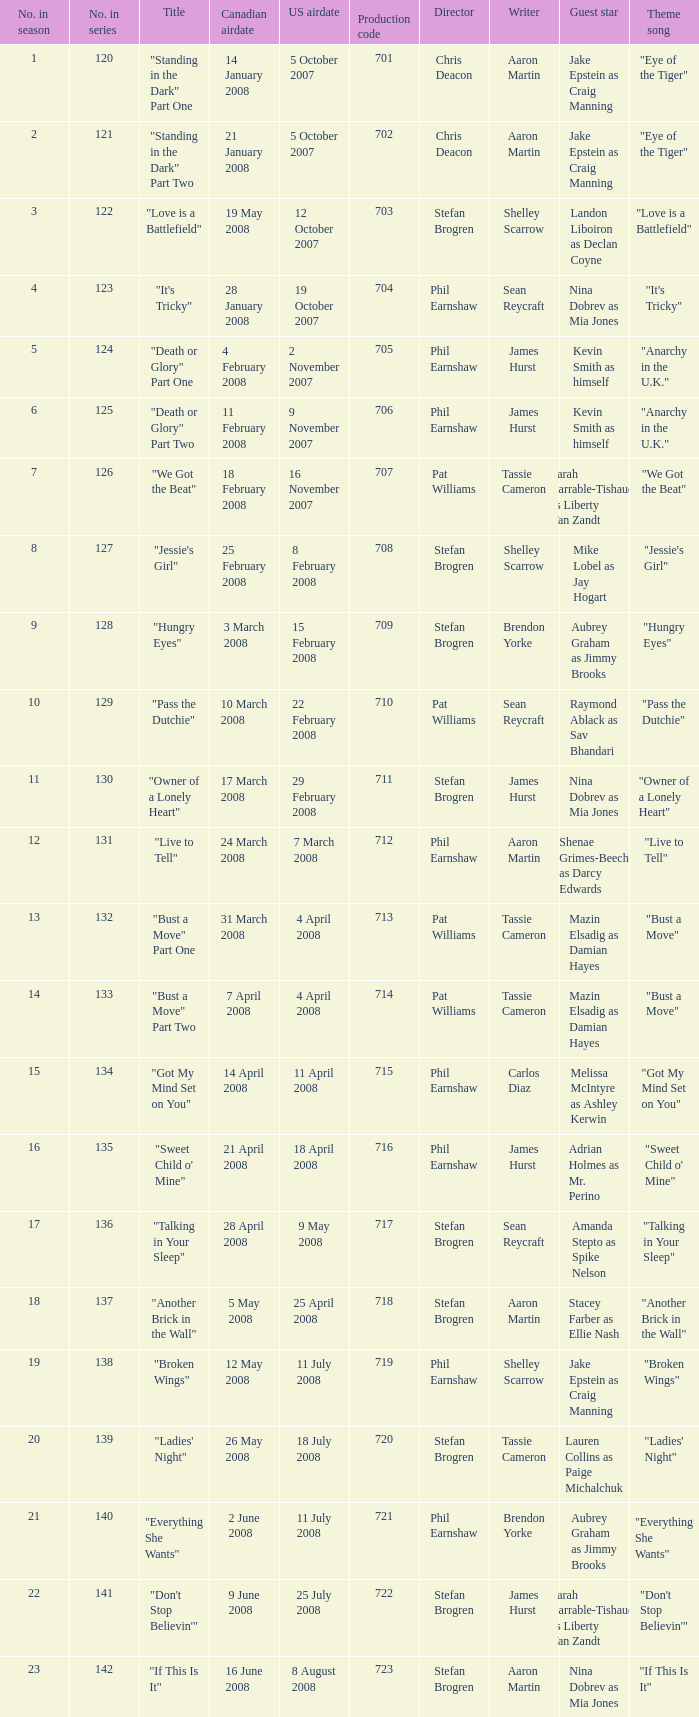The episode titled "don't stop believin'" was what highest number of the season? 22.0. Write the full table. {'header': ['No. in season', 'No. in series', 'Title', 'Canadian airdate', 'US airdate', 'Production code', 'Director', 'Writer', 'Guest star', 'Theme song'], 'rows': [['1', '120', '"Standing in the Dark" Part One', '14 January 2008', '5 October 2007', '701', 'Chris Deacon', 'Aaron Martin', 'Jake Epstein as Craig Manning', '"Eye of the Tiger"'], ['2', '121', '"Standing in the Dark" Part Two', '21 January 2008', '5 October 2007', '702', 'Chris Deacon', 'Aaron Martin', 'Jake Epstein as Craig Manning', '"Eye of the Tiger"'], ['3', '122', '"Love is a Battlefield"', '19 May 2008', '12 October 2007', '703', 'Stefan Brogren', 'Shelley Scarrow', 'Landon Liboiron as Declan Coyne', '"Love is a Battlefield"'], ['4', '123', '"It\'s Tricky"', '28 January 2008', '19 October 2007', '704', 'Phil Earnshaw', 'Sean Reycraft', 'Nina Dobrev as Mia Jones', '"It\'s Tricky"'], ['5', '124', '"Death or Glory" Part One', '4 February 2008', '2 November 2007', '705', 'Phil Earnshaw', 'James Hurst', 'Kevin Smith as himself', '"Anarchy in the U.K."'], ['6', '125', '"Death or Glory" Part Two', '11 February 2008', '9 November 2007', '706', 'Phil Earnshaw', 'James Hurst', 'Kevin Smith as himself', '"Anarchy in the U.K."'], ['7', '126', '"We Got the Beat"', '18 February 2008', '16 November 2007', '707', 'Pat Williams', 'Tassie Cameron', 'Sarah Barrable-Tishauer as Liberty Van Zandt', '"We Got the Beat"'], ['8', '127', '"Jessie\'s Girl"', '25 February 2008', '8 February 2008', '708', 'Stefan Brogren', 'Shelley Scarrow', 'Mike Lobel as Jay Hogart', '"Jessie\'s Girl"'], ['9', '128', '"Hungry Eyes"', '3 March 2008', '15 February 2008', '709', 'Stefan Brogren', 'Brendon Yorke', 'Aubrey Graham as Jimmy Brooks', '"Hungry Eyes"'], ['10', '129', '"Pass the Dutchie"', '10 March 2008', '22 February 2008', '710', 'Pat Williams', 'Sean Reycraft', 'Raymond Ablack as Sav Bhandari', '"Pass the Dutchie"'], ['11', '130', '"Owner of a Lonely Heart"', '17 March 2008', '29 February 2008', '711', 'Stefan Brogren', 'James Hurst', 'Nina Dobrev as Mia Jones', '"Owner of a Lonely Heart"'], ['12', '131', '"Live to Tell"', '24 March 2008', '7 March 2008', '712', 'Phil Earnshaw', 'Aaron Martin', 'Shenae Grimes-Beech as Darcy Edwards', '"Live to Tell"'], ['13', '132', '"Bust a Move" Part One', '31 March 2008', '4 April 2008', '713', 'Pat Williams', 'Tassie Cameron', 'Mazin Elsadig as Damian Hayes', '"Bust a Move"'], ['14', '133', '"Bust a Move" Part Two', '7 April 2008', '4 April 2008', '714', 'Pat Williams', 'Tassie Cameron', 'Mazin Elsadig as Damian Hayes', '"Bust a Move"'], ['15', '134', '"Got My Mind Set on You"', '14 April 2008', '11 April 2008', '715', 'Phil Earnshaw', 'Carlos Diaz', 'Melissa McIntyre as Ashley Kerwin', '"Got My Mind Set on You"'], ['16', '135', '"Sweet Child o\' Mine"', '21 April 2008', '18 April 2008', '716', 'Phil Earnshaw', 'James Hurst', 'Adrian Holmes as Mr. Perino', '"Sweet Child o\' Mine"'], ['17', '136', '"Talking in Your Sleep"', '28 April 2008', '9 May 2008', '717', 'Stefan Brogren', 'Sean Reycraft', 'Amanda Stepto as Spike Nelson', '"Talking in Your Sleep"'], ['18', '137', '"Another Brick in the Wall"', '5 May 2008', '25 April 2008', '718', 'Stefan Brogren', 'Aaron Martin', 'Stacey Farber as Ellie Nash', '"Another Brick in the Wall"'], ['19', '138', '"Broken Wings"', '12 May 2008', '11 July 2008', '719', 'Phil Earnshaw', 'Shelley Scarrow', 'Jake Epstein as Craig Manning', '"Broken Wings"'], ['20', '139', '"Ladies\' Night"', '26 May 2008', '18 July 2008', '720', 'Stefan Brogren', 'Tassie Cameron', 'Lauren Collins as Paige Michalchuk', '"Ladies\' Night"'], ['21', '140', '"Everything She Wants"', '2 June 2008', '11 July 2008', '721', 'Phil Earnshaw', 'Brendon Yorke', 'Aubrey Graham as Jimmy Brooks', '"Everything She Wants"'], ['22', '141', '"Don\'t Stop Believin\'"', '9 June 2008', '25 July 2008', '722', 'Stefan Brogren', 'James Hurst', 'Sarah Barrable-Tishauer as Liberty Van Zandt', '"Don\'t Stop Believin\'"'], ['23', '142', '"If This Is It"', '16 June 2008', '8 August 2008', '723', 'Stefan Brogren', 'Aaron Martin', 'Nina Dobrev as Mia Jones', '"If This Is It"']]} 